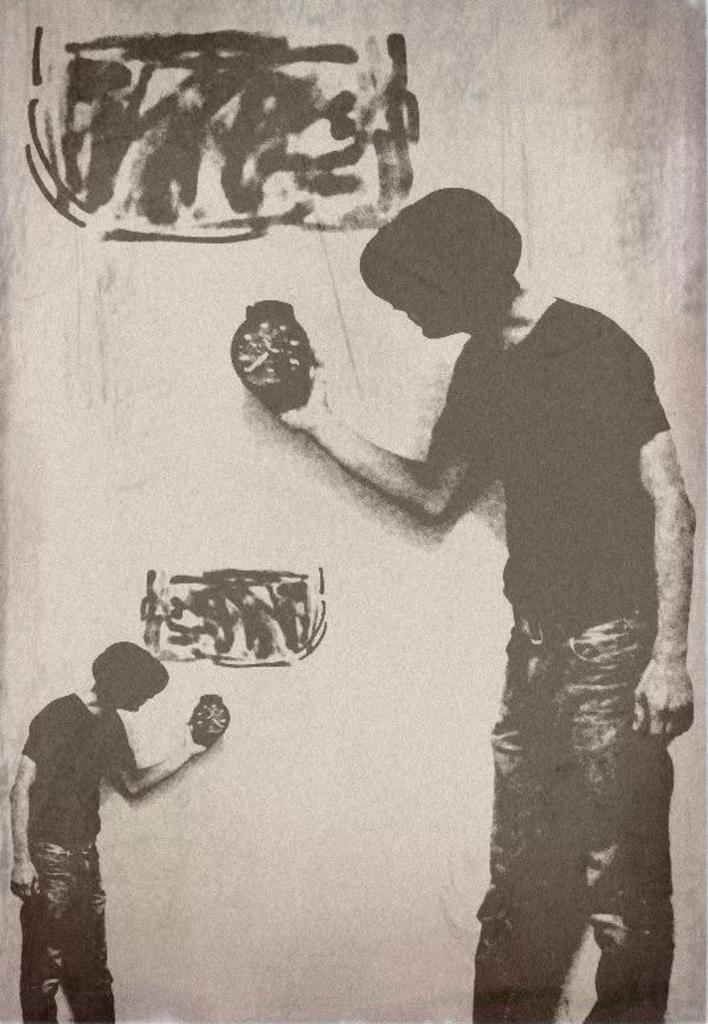How many people are in the foreground of the poster? There are two persons in the foreground of the poster. What are the persons holding in their hands? The persons are holding wrist watches in their hands. What can be seen near the persons in the poster? There are rectangular boxes near the persons. What type of circle can be seen in the poster? There is no circle present in the poster. Is there a stranger in the poster? The provided facts do not mention any strangers in the poster. Can you hear thunder in the poster? The provided facts do not mention any sounds, including thunder, in the poster. 